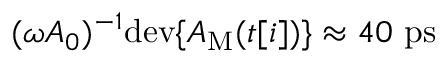Convert formula to latex. <formula><loc_0><loc_0><loc_500><loc_500>( \omega A _ { 0 } ) ^ { - 1 } d e v \{ A _ { M } ( t [ i ] ) \} \approx 4 0 p s</formula> 